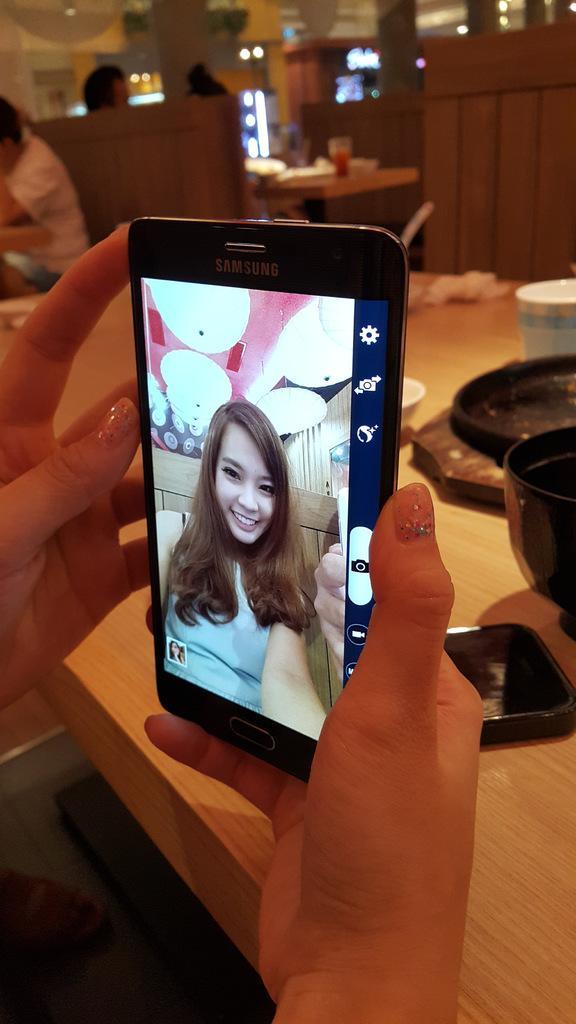Describe this image in one or two sentences. In this picture I can see the hands of a person holding a mobile. There are three persons sitting and there are some objects on the tables, and in the background there are lights. 